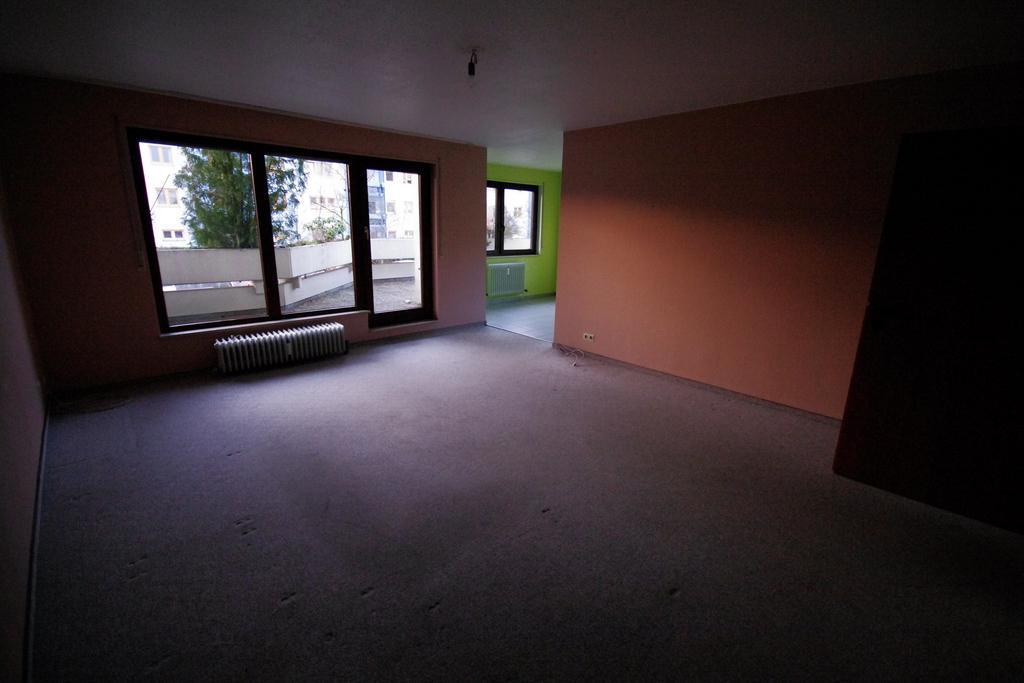Could you give a brief overview of what you see in this image? It is a house and the walls of the house are painted in different colors,there are three windows to a wall and behind the windows there are some other buildings and a tree. 